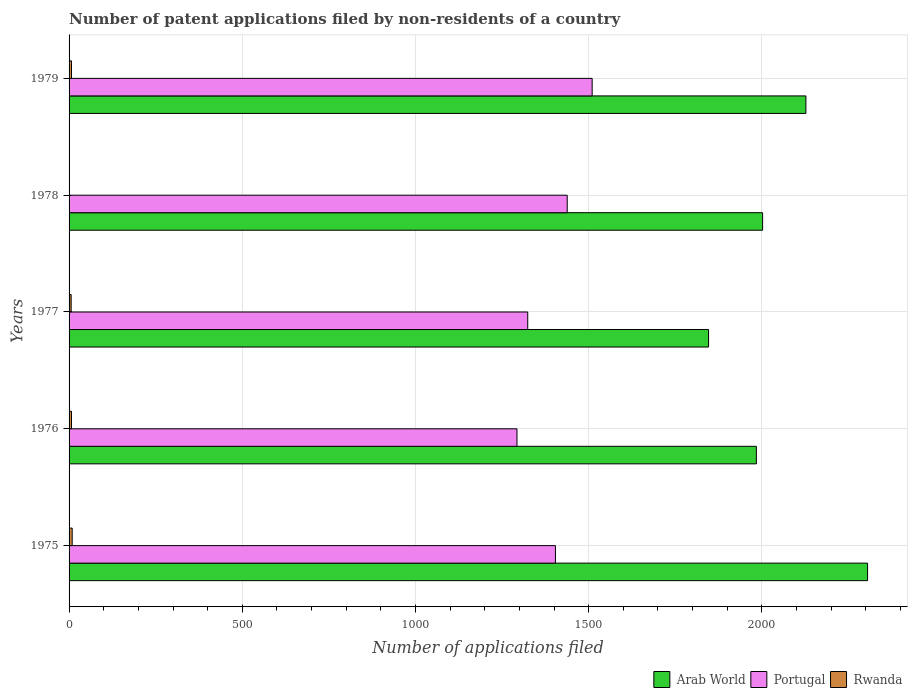How many groups of bars are there?
Offer a very short reply. 5. What is the label of the 5th group of bars from the top?
Offer a terse response. 1975. In how many cases, is the number of bars for a given year not equal to the number of legend labels?
Keep it short and to the point. 0. What is the number of applications filed in Portugal in 1977?
Provide a short and direct response. 1324. Across all years, what is the maximum number of applications filed in Arab World?
Make the answer very short. 2305. Across all years, what is the minimum number of applications filed in Rwanda?
Your answer should be compact. 1. In which year was the number of applications filed in Rwanda maximum?
Ensure brevity in your answer.  1975. In which year was the number of applications filed in Portugal minimum?
Provide a succinct answer. 1976. What is the total number of applications filed in Arab World in the graph?
Make the answer very short. 1.03e+04. What is the difference between the number of applications filed in Portugal in 1975 and that in 1979?
Offer a very short reply. -106. What is the difference between the number of applications filed in Rwanda in 1979 and the number of applications filed in Portugal in 1978?
Provide a succinct answer. -1431. What is the average number of applications filed in Portugal per year?
Your response must be concise. 1393.8. In the year 1978, what is the difference between the number of applications filed in Portugal and number of applications filed in Arab World?
Ensure brevity in your answer.  -564. In how many years, is the number of applications filed in Arab World greater than 1500 ?
Make the answer very short. 5. What is the ratio of the number of applications filed in Rwanda in 1978 to that in 1979?
Your response must be concise. 0.14. What is the difference between the highest and the second highest number of applications filed in Arab World?
Your response must be concise. 178. Is the sum of the number of applications filed in Portugal in 1976 and 1977 greater than the maximum number of applications filed in Rwanda across all years?
Offer a terse response. Yes. What does the 3rd bar from the top in 1977 represents?
Offer a very short reply. Arab World. What does the 1st bar from the bottom in 1975 represents?
Make the answer very short. Arab World. Is it the case that in every year, the sum of the number of applications filed in Rwanda and number of applications filed in Arab World is greater than the number of applications filed in Portugal?
Give a very brief answer. Yes. How many bars are there?
Your answer should be very brief. 15. Are all the bars in the graph horizontal?
Give a very brief answer. Yes. How many years are there in the graph?
Ensure brevity in your answer.  5. What is the difference between two consecutive major ticks on the X-axis?
Provide a succinct answer. 500. Are the values on the major ticks of X-axis written in scientific E-notation?
Provide a short and direct response. No. Does the graph contain grids?
Offer a very short reply. Yes. Where does the legend appear in the graph?
Your answer should be very brief. Bottom right. How many legend labels are there?
Your response must be concise. 3. How are the legend labels stacked?
Keep it short and to the point. Horizontal. What is the title of the graph?
Ensure brevity in your answer.  Number of patent applications filed by non-residents of a country. Does "United States" appear as one of the legend labels in the graph?
Keep it short and to the point. No. What is the label or title of the X-axis?
Offer a very short reply. Number of applications filed. What is the label or title of the Y-axis?
Give a very brief answer. Years. What is the Number of applications filed of Arab World in 1975?
Provide a short and direct response. 2305. What is the Number of applications filed in Portugal in 1975?
Make the answer very short. 1404. What is the Number of applications filed in Arab World in 1976?
Provide a short and direct response. 1984. What is the Number of applications filed in Portugal in 1976?
Provide a short and direct response. 1293. What is the Number of applications filed of Rwanda in 1976?
Make the answer very short. 7. What is the Number of applications filed in Arab World in 1977?
Make the answer very short. 1846. What is the Number of applications filed of Portugal in 1977?
Offer a terse response. 1324. What is the Number of applications filed in Rwanda in 1977?
Your response must be concise. 6. What is the Number of applications filed of Arab World in 1978?
Your answer should be very brief. 2002. What is the Number of applications filed of Portugal in 1978?
Ensure brevity in your answer.  1438. What is the Number of applications filed in Arab World in 1979?
Your answer should be compact. 2127. What is the Number of applications filed of Portugal in 1979?
Give a very brief answer. 1510. Across all years, what is the maximum Number of applications filed in Arab World?
Your answer should be compact. 2305. Across all years, what is the maximum Number of applications filed of Portugal?
Give a very brief answer. 1510. Across all years, what is the minimum Number of applications filed in Arab World?
Your response must be concise. 1846. Across all years, what is the minimum Number of applications filed in Portugal?
Offer a terse response. 1293. What is the total Number of applications filed of Arab World in the graph?
Your answer should be compact. 1.03e+04. What is the total Number of applications filed of Portugal in the graph?
Give a very brief answer. 6969. What is the total Number of applications filed in Rwanda in the graph?
Your answer should be very brief. 30. What is the difference between the Number of applications filed in Arab World in 1975 and that in 1976?
Your answer should be very brief. 321. What is the difference between the Number of applications filed of Portugal in 1975 and that in 1976?
Provide a succinct answer. 111. What is the difference between the Number of applications filed in Rwanda in 1975 and that in 1976?
Make the answer very short. 2. What is the difference between the Number of applications filed of Arab World in 1975 and that in 1977?
Make the answer very short. 459. What is the difference between the Number of applications filed in Portugal in 1975 and that in 1977?
Offer a very short reply. 80. What is the difference between the Number of applications filed of Arab World in 1975 and that in 1978?
Give a very brief answer. 303. What is the difference between the Number of applications filed of Portugal in 1975 and that in 1978?
Provide a succinct answer. -34. What is the difference between the Number of applications filed in Rwanda in 1975 and that in 1978?
Provide a succinct answer. 8. What is the difference between the Number of applications filed in Arab World in 1975 and that in 1979?
Make the answer very short. 178. What is the difference between the Number of applications filed of Portugal in 1975 and that in 1979?
Provide a short and direct response. -106. What is the difference between the Number of applications filed of Arab World in 1976 and that in 1977?
Make the answer very short. 138. What is the difference between the Number of applications filed of Portugal in 1976 and that in 1977?
Make the answer very short. -31. What is the difference between the Number of applications filed in Arab World in 1976 and that in 1978?
Ensure brevity in your answer.  -18. What is the difference between the Number of applications filed of Portugal in 1976 and that in 1978?
Make the answer very short. -145. What is the difference between the Number of applications filed of Arab World in 1976 and that in 1979?
Your response must be concise. -143. What is the difference between the Number of applications filed in Portugal in 1976 and that in 1979?
Offer a terse response. -217. What is the difference between the Number of applications filed of Arab World in 1977 and that in 1978?
Your answer should be very brief. -156. What is the difference between the Number of applications filed of Portugal in 1977 and that in 1978?
Offer a very short reply. -114. What is the difference between the Number of applications filed of Rwanda in 1977 and that in 1978?
Offer a terse response. 5. What is the difference between the Number of applications filed of Arab World in 1977 and that in 1979?
Your response must be concise. -281. What is the difference between the Number of applications filed in Portugal in 1977 and that in 1979?
Offer a very short reply. -186. What is the difference between the Number of applications filed of Arab World in 1978 and that in 1979?
Make the answer very short. -125. What is the difference between the Number of applications filed in Portugal in 1978 and that in 1979?
Your answer should be very brief. -72. What is the difference between the Number of applications filed of Rwanda in 1978 and that in 1979?
Your response must be concise. -6. What is the difference between the Number of applications filed of Arab World in 1975 and the Number of applications filed of Portugal in 1976?
Provide a short and direct response. 1012. What is the difference between the Number of applications filed in Arab World in 1975 and the Number of applications filed in Rwanda in 1976?
Give a very brief answer. 2298. What is the difference between the Number of applications filed in Portugal in 1975 and the Number of applications filed in Rwanda in 1976?
Provide a succinct answer. 1397. What is the difference between the Number of applications filed of Arab World in 1975 and the Number of applications filed of Portugal in 1977?
Your answer should be compact. 981. What is the difference between the Number of applications filed of Arab World in 1975 and the Number of applications filed of Rwanda in 1977?
Give a very brief answer. 2299. What is the difference between the Number of applications filed of Portugal in 1975 and the Number of applications filed of Rwanda in 1977?
Make the answer very short. 1398. What is the difference between the Number of applications filed of Arab World in 1975 and the Number of applications filed of Portugal in 1978?
Offer a terse response. 867. What is the difference between the Number of applications filed of Arab World in 1975 and the Number of applications filed of Rwanda in 1978?
Your answer should be very brief. 2304. What is the difference between the Number of applications filed of Portugal in 1975 and the Number of applications filed of Rwanda in 1978?
Keep it short and to the point. 1403. What is the difference between the Number of applications filed in Arab World in 1975 and the Number of applications filed in Portugal in 1979?
Your answer should be compact. 795. What is the difference between the Number of applications filed in Arab World in 1975 and the Number of applications filed in Rwanda in 1979?
Your response must be concise. 2298. What is the difference between the Number of applications filed in Portugal in 1975 and the Number of applications filed in Rwanda in 1979?
Offer a very short reply. 1397. What is the difference between the Number of applications filed of Arab World in 1976 and the Number of applications filed of Portugal in 1977?
Offer a terse response. 660. What is the difference between the Number of applications filed of Arab World in 1976 and the Number of applications filed of Rwanda in 1977?
Provide a succinct answer. 1978. What is the difference between the Number of applications filed of Portugal in 1976 and the Number of applications filed of Rwanda in 1977?
Your answer should be very brief. 1287. What is the difference between the Number of applications filed of Arab World in 1976 and the Number of applications filed of Portugal in 1978?
Make the answer very short. 546. What is the difference between the Number of applications filed in Arab World in 1976 and the Number of applications filed in Rwanda in 1978?
Your answer should be compact. 1983. What is the difference between the Number of applications filed in Portugal in 1976 and the Number of applications filed in Rwanda in 1978?
Ensure brevity in your answer.  1292. What is the difference between the Number of applications filed in Arab World in 1976 and the Number of applications filed in Portugal in 1979?
Your answer should be very brief. 474. What is the difference between the Number of applications filed in Arab World in 1976 and the Number of applications filed in Rwanda in 1979?
Provide a succinct answer. 1977. What is the difference between the Number of applications filed of Portugal in 1976 and the Number of applications filed of Rwanda in 1979?
Make the answer very short. 1286. What is the difference between the Number of applications filed in Arab World in 1977 and the Number of applications filed in Portugal in 1978?
Your response must be concise. 408. What is the difference between the Number of applications filed in Arab World in 1977 and the Number of applications filed in Rwanda in 1978?
Provide a succinct answer. 1845. What is the difference between the Number of applications filed of Portugal in 1977 and the Number of applications filed of Rwanda in 1978?
Keep it short and to the point. 1323. What is the difference between the Number of applications filed in Arab World in 1977 and the Number of applications filed in Portugal in 1979?
Make the answer very short. 336. What is the difference between the Number of applications filed of Arab World in 1977 and the Number of applications filed of Rwanda in 1979?
Keep it short and to the point. 1839. What is the difference between the Number of applications filed of Portugal in 1977 and the Number of applications filed of Rwanda in 1979?
Offer a very short reply. 1317. What is the difference between the Number of applications filed in Arab World in 1978 and the Number of applications filed in Portugal in 1979?
Your answer should be very brief. 492. What is the difference between the Number of applications filed of Arab World in 1978 and the Number of applications filed of Rwanda in 1979?
Offer a terse response. 1995. What is the difference between the Number of applications filed in Portugal in 1978 and the Number of applications filed in Rwanda in 1979?
Provide a succinct answer. 1431. What is the average Number of applications filed in Arab World per year?
Offer a very short reply. 2052.8. What is the average Number of applications filed of Portugal per year?
Your response must be concise. 1393.8. In the year 1975, what is the difference between the Number of applications filed of Arab World and Number of applications filed of Portugal?
Provide a short and direct response. 901. In the year 1975, what is the difference between the Number of applications filed of Arab World and Number of applications filed of Rwanda?
Your response must be concise. 2296. In the year 1975, what is the difference between the Number of applications filed of Portugal and Number of applications filed of Rwanda?
Provide a short and direct response. 1395. In the year 1976, what is the difference between the Number of applications filed in Arab World and Number of applications filed in Portugal?
Ensure brevity in your answer.  691. In the year 1976, what is the difference between the Number of applications filed in Arab World and Number of applications filed in Rwanda?
Your answer should be very brief. 1977. In the year 1976, what is the difference between the Number of applications filed of Portugal and Number of applications filed of Rwanda?
Offer a very short reply. 1286. In the year 1977, what is the difference between the Number of applications filed of Arab World and Number of applications filed of Portugal?
Give a very brief answer. 522. In the year 1977, what is the difference between the Number of applications filed of Arab World and Number of applications filed of Rwanda?
Keep it short and to the point. 1840. In the year 1977, what is the difference between the Number of applications filed of Portugal and Number of applications filed of Rwanda?
Make the answer very short. 1318. In the year 1978, what is the difference between the Number of applications filed of Arab World and Number of applications filed of Portugal?
Provide a short and direct response. 564. In the year 1978, what is the difference between the Number of applications filed of Arab World and Number of applications filed of Rwanda?
Your answer should be compact. 2001. In the year 1978, what is the difference between the Number of applications filed of Portugal and Number of applications filed of Rwanda?
Offer a very short reply. 1437. In the year 1979, what is the difference between the Number of applications filed in Arab World and Number of applications filed in Portugal?
Your response must be concise. 617. In the year 1979, what is the difference between the Number of applications filed of Arab World and Number of applications filed of Rwanda?
Offer a very short reply. 2120. In the year 1979, what is the difference between the Number of applications filed of Portugal and Number of applications filed of Rwanda?
Give a very brief answer. 1503. What is the ratio of the Number of applications filed of Arab World in 1975 to that in 1976?
Offer a terse response. 1.16. What is the ratio of the Number of applications filed of Portugal in 1975 to that in 1976?
Give a very brief answer. 1.09. What is the ratio of the Number of applications filed in Rwanda in 1975 to that in 1976?
Your response must be concise. 1.29. What is the ratio of the Number of applications filed of Arab World in 1975 to that in 1977?
Give a very brief answer. 1.25. What is the ratio of the Number of applications filed in Portugal in 1975 to that in 1977?
Offer a very short reply. 1.06. What is the ratio of the Number of applications filed of Arab World in 1975 to that in 1978?
Your answer should be very brief. 1.15. What is the ratio of the Number of applications filed in Portugal in 1975 to that in 1978?
Ensure brevity in your answer.  0.98. What is the ratio of the Number of applications filed in Arab World in 1975 to that in 1979?
Keep it short and to the point. 1.08. What is the ratio of the Number of applications filed in Portugal in 1975 to that in 1979?
Make the answer very short. 0.93. What is the ratio of the Number of applications filed in Rwanda in 1975 to that in 1979?
Your answer should be compact. 1.29. What is the ratio of the Number of applications filed in Arab World in 1976 to that in 1977?
Your answer should be very brief. 1.07. What is the ratio of the Number of applications filed of Portugal in 1976 to that in 1977?
Make the answer very short. 0.98. What is the ratio of the Number of applications filed in Rwanda in 1976 to that in 1977?
Keep it short and to the point. 1.17. What is the ratio of the Number of applications filed in Arab World in 1976 to that in 1978?
Your response must be concise. 0.99. What is the ratio of the Number of applications filed in Portugal in 1976 to that in 1978?
Provide a short and direct response. 0.9. What is the ratio of the Number of applications filed in Rwanda in 1976 to that in 1978?
Provide a short and direct response. 7. What is the ratio of the Number of applications filed in Arab World in 1976 to that in 1979?
Provide a succinct answer. 0.93. What is the ratio of the Number of applications filed of Portugal in 1976 to that in 1979?
Ensure brevity in your answer.  0.86. What is the ratio of the Number of applications filed in Arab World in 1977 to that in 1978?
Provide a short and direct response. 0.92. What is the ratio of the Number of applications filed of Portugal in 1977 to that in 1978?
Your answer should be compact. 0.92. What is the ratio of the Number of applications filed of Arab World in 1977 to that in 1979?
Your answer should be very brief. 0.87. What is the ratio of the Number of applications filed in Portugal in 1977 to that in 1979?
Your answer should be compact. 0.88. What is the ratio of the Number of applications filed of Portugal in 1978 to that in 1979?
Make the answer very short. 0.95. What is the ratio of the Number of applications filed in Rwanda in 1978 to that in 1979?
Offer a very short reply. 0.14. What is the difference between the highest and the second highest Number of applications filed of Arab World?
Keep it short and to the point. 178. What is the difference between the highest and the lowest Number of applications filed of Arab World?
Keep it short and to the point. 459. What is the difference between the highest and the lowest Number of applications filed in Portugal?
Your response must be concise. 217. What is the difference between the highest and the lowest Number of applications filed of Rwanda?
Provide a succinct answer. 8. 